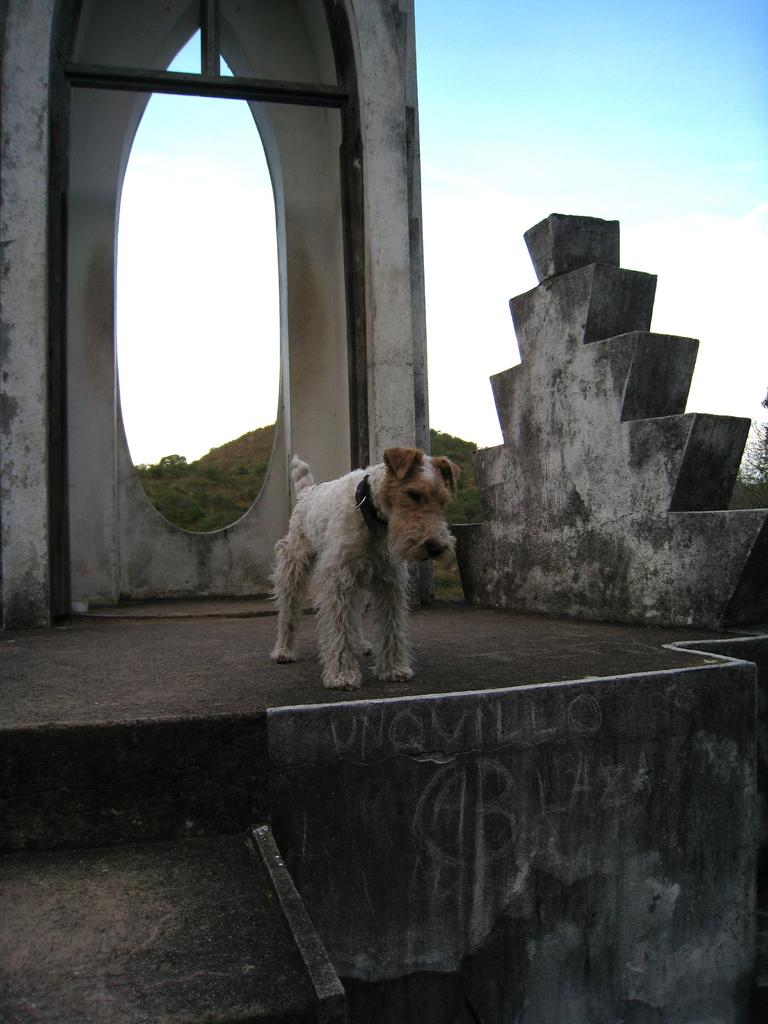What animal can be seen standing in the image? There is a dog standing in the image. What type of structure is present in the image? There is a wooden arch in the image. What natural feature is visible in the image? There is a hill with trees in the image. What man-made feature can be seen in the image? There is a wall in the image. What type of whip is being used by the dog in the image? There is no whip present in the image, and the dog is not using any tool or object. 